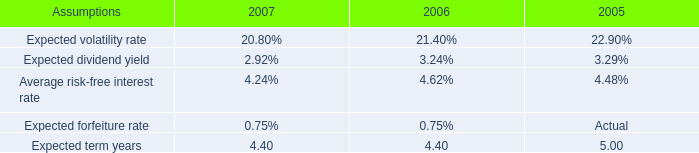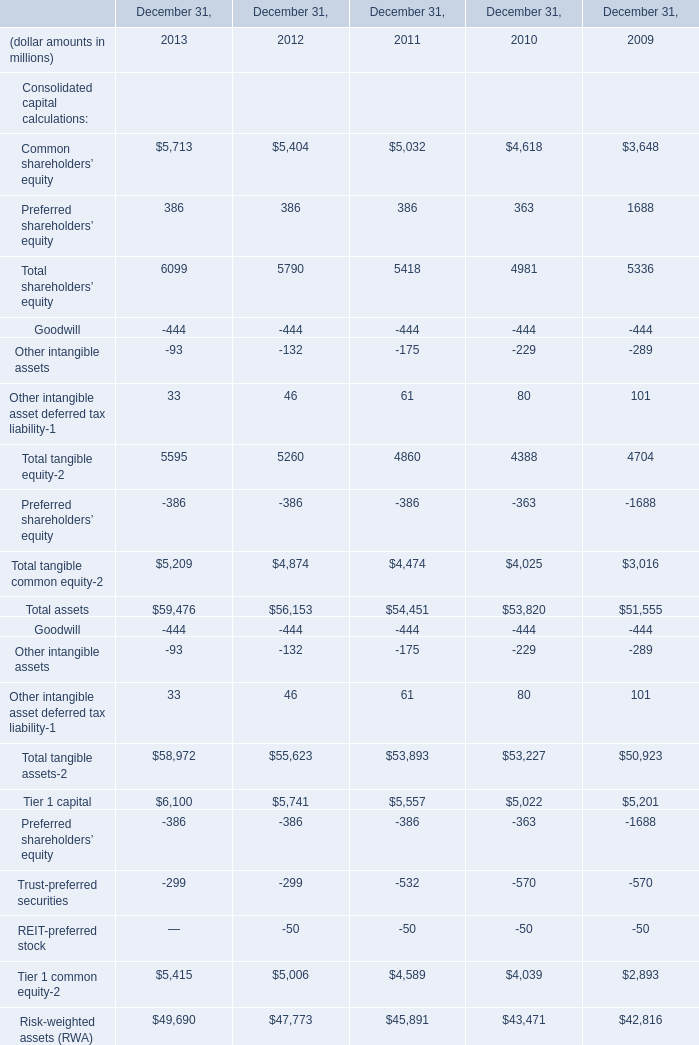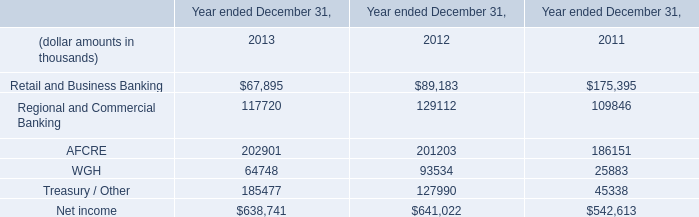in 2007 what was the percent of the shared based compensation associated with stock options 
Computations: (13 / 26)
Answer: 0.5. 